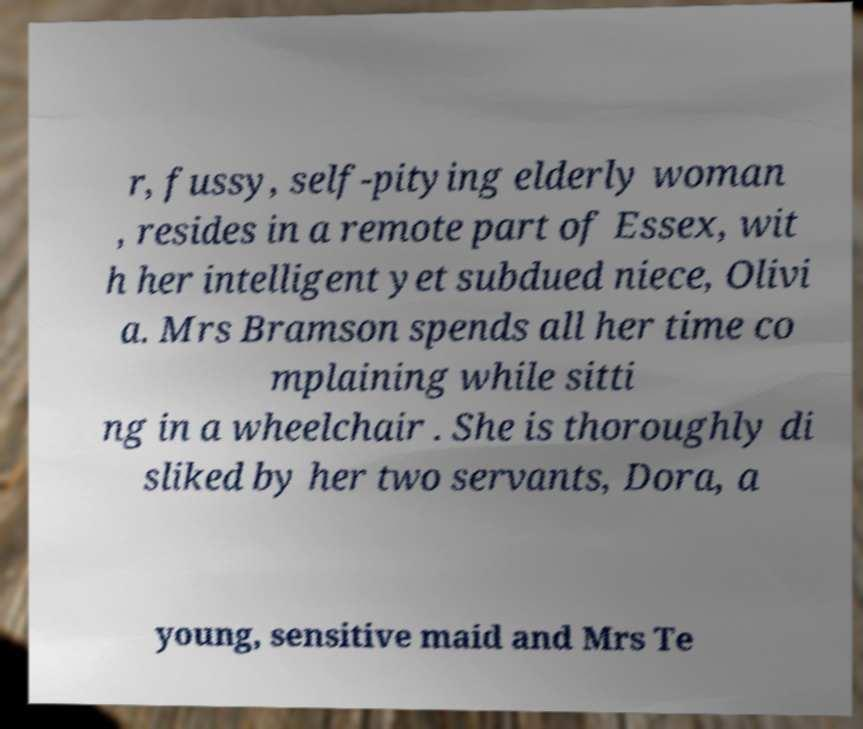Please identify and transcribe the text found in this image. r, fussy, self-pitying elderly woman , resides in a remote part of Essex, wit h her intelligent yet subdued niece, Olivi a. Mrs Bramson spends all her time co mplaining while sitti ng in a wheelchair . She is thoroughly di sliked by her two servants, Dora, a young, sensitive maid and Mrs Te 